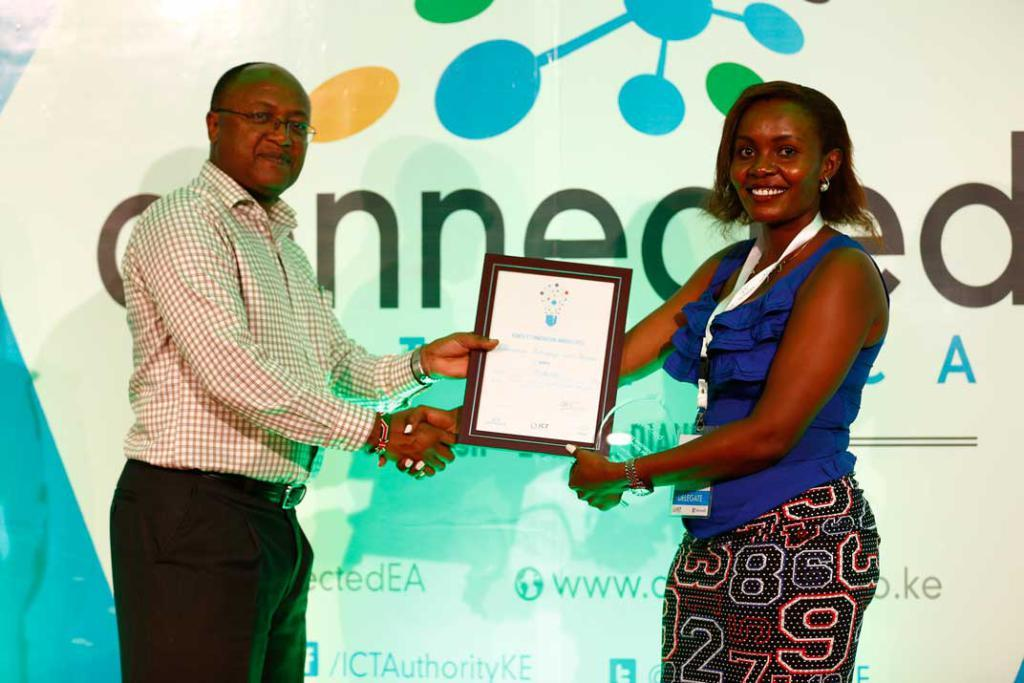How many people are in the image? There are two people in the image. What are the two people doing? The two people are shaking hands and holding a photo frame. What can be seen in the background of the image? There is a banner visible in the background of the image. How many boats are visible in the image? There are no boats visible in the image. What type of ground can be seen in the image? The image does not show any ground; it appears to be an indoor setting. 